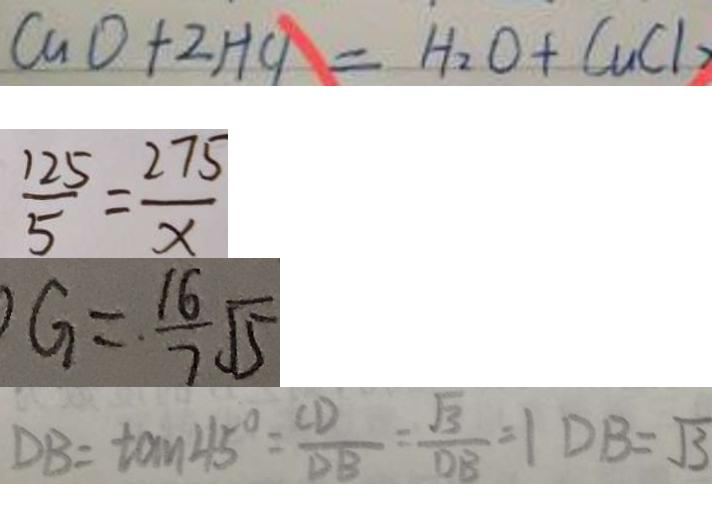Convert formula to latex. <formula><loc_0><loc_0><loc_500><loc_500>C u O + 2 H C l = H _ { 2 } O + C u C l _ { 2 } 
 \frac { 1 2 5 } { 5 } = \frac { 2 7 5 } { x } 
 G = \frac { 1 6 } { 7 } \sqrt { 5 } 
 D B = \tan 4 5 ^ { \circ } = \frac { C D } { D B } = \frac { \sqrt { 3 } } { D B } = 1 D B = \sqrt { 3 }</formula> 